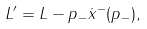<formula> <loc_0><loc_0><loc_500><loc_500>L ^ { \prime } = L - p _ { - } \dot { x } ^ { - } ( p _ { - } ) ,</formula> 